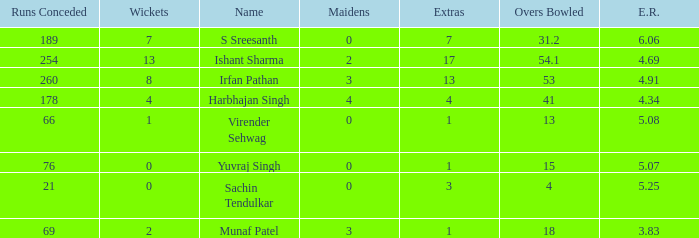Name the name for when overs bowled is 31.2 S Sreesanth. 